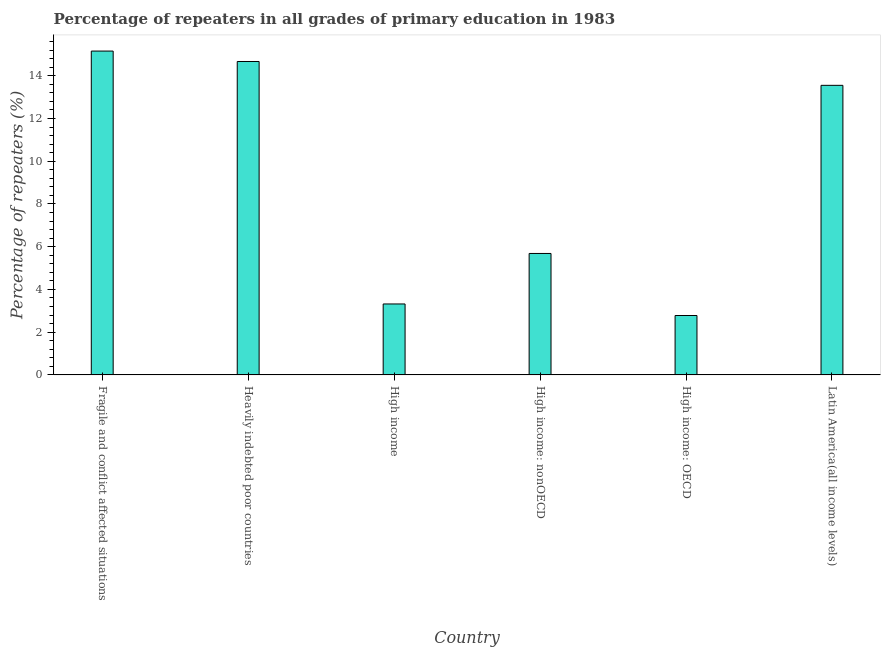What is the title of the graph?
Keep it short and to the point. Percentage of repeaters in all grades of primary education in 1983. What is the label or title of the X-axis?
Give a very brief answer. Country. What is the label or title of the Y-axis?
Your response must be concise. Percentage of repeaters (%). What is the percentage of repeaters in primary education in High income: OECD?
Your response must be concise. 2.78. Across all countries, what is the maximum percentage of repeaters in primary education?
Offer a very short reply. 15.16. Across all countries, what is the minimum percentage of repeaters in primary education?
Make the answer very short. 2.78. In which country was the percentage of repeaters in primary education maximum?
Provide a succinct answer. Fragile and conflict affected situations. In which country was the percentage of repeaters in primary education minimum?
Your answer should be very brief. High income: OECD. What is the sum of the percentage of repeaters in primary education?
Your response must be concise. 55.17. What is the difference between the percentage of repeaters in primary education in Heavily indebted poor countries and Latin America(all income levels)?
Provide a succinct answer. 1.12. What is the average percentage of repeaters in primary education per country?
Your answer should be compact. 9.19. What is the median percentage of repeaters in primary education?
Your answer should be very brief. 9.62. In how many countries, is the percentage of repeaters in primary education greater than 14.4 %?
Offer a terse response. 2. What is the ratio of the percentage of repeaters in primary education in Fragile and conflict affected situations to that in High income: nonOECD?
Provide a succinct answer. 2.67. Is the percentage of repeaters in primary education in High income: nonOECD less than that in Latin America(all income levels)?
Offer a terse response. Yes. Is the difference between the percentage of repeaters in primary education in High income and High income: OECD greater than the difference between any two countries?
Offer a very short reply. No. What is the difference between the highest and the second highest percentage of repeaters in primary education?
Keep it short and to the point. 0.49. What is the difference between the highest and the lowest percentage of repeaters in primary education?
Your answer should be compact. 12.38. In how many countries, is the percentage of repeaters in primary education greater than the average percentage of repeaters in primary education taken over all countries?
Offer a terse response. 3. How many bars are there?
Offer a very short reply. 6. Are all the bars in the graph horizontal?
Keep it short and to the point. No. Are the values on the major ticks of Y-axis written in scientific E-notation?
Your response must be concise. No. What is the Percentage of repeaters (%) in Fragile and conflict affected situations?
Your answer should be very brief. 15.16. What is the Percentage of repeaters (%) in Heavily indebted poor countries?
Your answer should be very brief. 14.67. What is the Percentage of repeaters (%) in High income?
Offer a terse response. 3.32. What is the Percentage of repeaters (%) in High income: nonOECD?
Make the answer very short. 5.68. What is the Percentage of repeaters (%) of High income: OECD?
Your answer should be compact. 2.78. What is the Percentage of repeaters (%) in Latin America(all income levels)?
Provide a succinct answer. 13.55. What is the difference between the Percentage of repeaters (%) in Fragile and conflict affected situations and Heavily indebted poor countries?
Provide a short and direct response. 0.49. What is the difference between the Percentage of repeaters (%) in Fragile and conflict affected situations and High income?
Make the answer very short. 11.84. What is the difference between the Percentage of repeaters (%) in Fragile and conflict affected situations and High income: nonOECD?
Offer a terse response. 9.47. What is the difference between the Percentage of repeaters (%) in Fragile and conflict affected situations and High income: OECD?
Provide a succinct answer. 12.38. What is the difference between the Percentage of repeaters (%) in Fragile and conflict affected situations and Latin America(all income levels)?
Offer a very short reply. 1.6. What is the difference between the Percentage of repeaters (%) in Heavily indebted poor countries and High income?
Provide a short and direct response. 11.35. What is the difference between the Percentage of repeaters (%) in Heavily indebted poor countries and High income: nonOECD?
Make the answer very short. 8.99. What is the difference between the Percentage of repeaters (%) in Heavily indebted poor countries and High income: OECD?
Your answer should be compact. 11.89. What is the difference between the Percentage of repeaters (%) in Heavily indebted poor countries and Latin America(all income levels)?
Your response must be concise. 1.12. What is the difference between the Percentage of repeaters (%) in High income and High income: nonOECD?
Keep it short and to the point. -2.36. What is the difference between the Percentage of repeaters (%) in High income and High income: OECD?
Your response must be concise. 0.54. What is the difference between the Percentage of repeaters (%) in High income and Latin America(all income levels)?
Your response must be concise. -10.23. What is the difference between the Percentage of repeaters (%) in High income: nonOECD and High income: OECD?
Keep it short and to the point. 2.9. What is the difference between the Percentage of repeaters (%) in High income: nonOECD and Latin America(all income levels)?
Make the answer very short. -7.87. What is the difference between the Percentage of repeaters (%) in High income: OECD and Latin America(all income levels)?
Provide a short and direct response. -10.77. What is the ratio of the Percentage of repeaters (%) in Fragile and conflict affected situations to that in Heavily indebted poor countries?
Your answer should be very brief. 1.03. What is the ratio of the Percentage of repeaters (%) in Fragile and conflict affected situations to that in High income?
Provide a short and direct response. 4.57. What is the ratio of the Percentage of repeaters (%) in Fragile and conflict affected situations to that in High income: nonOECD?
Ensure brevity in your answer.  2.67. What is the ratio of the Percentage of repeaters (%) in Fragile and conflict affected situations to that in High income: OECD?
Provide a short and direct response. 5.45. What is the ratio of the Percentage of repeaters (%) in Fragile and conflict affected situations to that in Latin America(all income levels)?
Ensure brevity in your answer.  1.12. What is the ratio of the Percentage of repeaters (%) in Heavily indebted poor countries to that in High income?
Provide a short and direct response. 4.42. What is the ratio of the Percentage of repeaters (%) in Heavily indebted poor countries to that in High income: nonOECD?
Offer a terse response. 2.58. What is the ratio of the Percentage of repeaters (%) in Heavily indebted poor countries to that in High income: OECD?
Make the answer very short. 5.28. What is the ratio of the Percentage of repeaters (%) in Heavily indebted poor countries to that in Latin America(all income levels)?
Offer a very short reply. 1.08. What is the ratio of the Percentage of repeaters (%) in High income to that in High income: nonOECD?
Your answer should be very brief. 0.58. What is the ratio of the Percentage of repeaters (%) in High income to that in High income: OECD?
Provide a short and direct response. 1.19. What is the ratio of the Percentage of repeaters (%) in High income to that in Latin America(all income levels)?
Keep it short and to the point. 0.24. What is the ratio of the Percentage of repeaters (%) in High income: nonOECD to that in High income: OECD?
Ensure brevity in your answer.  2.04. What is the ratio of the Percentage of repeaters (%) in High income: nonOECD to that in Latin America(all income levels)?
Provide a short and direct response. 0.42. What is the ratio of the Percentage of repeaters (%) in High income: OECD to that in Latin America(all income levels)?
Make the answer very short. 0.2. 